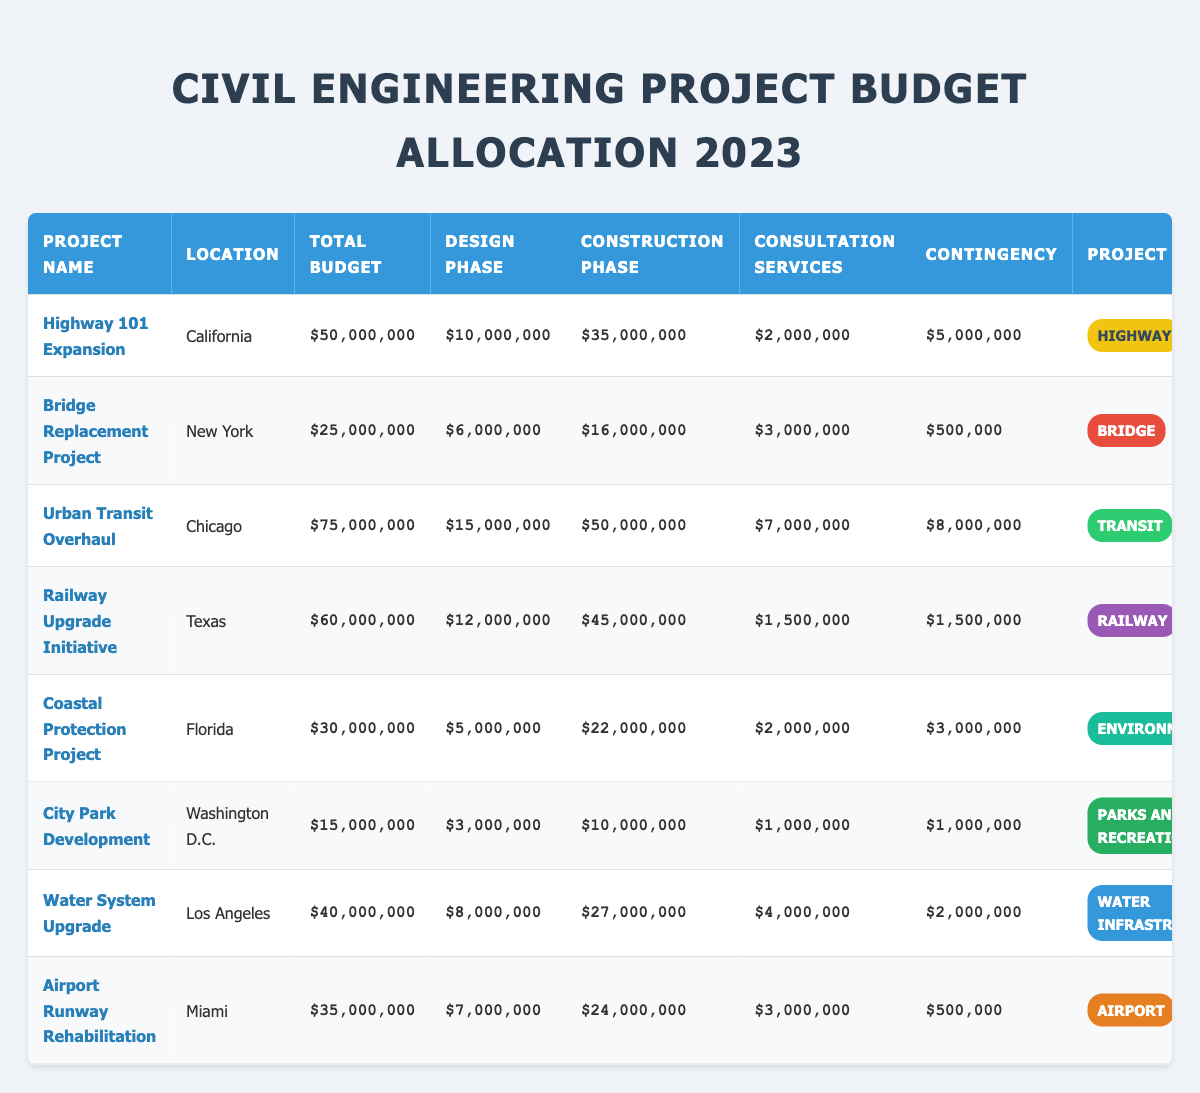What is the total budget for the Urban Transit Overhaul project? The table shows that the total budget allocated for the Urban Transit Overhaul project is $75,000,000.
Answer: $75,000,000 How much budget is allocated for the construction phase of the Railway Upgrade Initiative? The table indicates that the budget allocated for the construction phase of the Railway Upgrade Initiative is $45,000,000.
Answer: $45,000,000 Which project located in Florida has a total budget of $30,000,000? The Coastal Protection Project is located in Florida and has a total budget of $30,000,000, as shown in the table.
Answer: Coastal Protection Project What is the average total budget of all the projects listed? The total budgets are $50M, $25M, $75M, $60M, $30M, $15M, $40M, and $35M. Summing these gives $390M, which divided by 8 projects gives an average of $48.75M.
Answer: $48.75M Is the allocated budget for the design phase of the Highway 101 Expansion higher than $10M? The allocated budget for the design phase of the Highway 101 Expansion project is exactly $10M, so it is not higher than $10M.
Answer: No Which project has the longest duration, and how many months is it? Upon checking the durations, the Railway Upgrade Initiative has the longest duration of 36 months.
Answer: Railway Upgrade Initiative, 36 months What is the total contingency budget across all projects? The total contingency budgets are $5M, $0.5M, $8M, $1.5M, $3M, $1M, $2M, and $0.5M. Summing these gives $22.5M.
Answer: $22.5M Does the City Park Development project have a budget for consultation services? Yes, the City Park Development project has an allocated budget for consultation services of $1,000,000, as shown in the table.
Answer: Yes How much more is allocated to the construction phase than to the design phase in the Urban Transit Overhaul project? In the Urban Transit Overhaul project, $50M is allocated for construction and $15M for design. The difference is $50M - $15M = $35M.
Answer: $35M What is the percentage of the total budget allocated for consultation services in the Bridge Replacement Project? The consultation services budget is $3M out of a total budget of $25M. Thus, the percentage is ($3M / $25M) * 100 = 12%.
Answer: 12% 